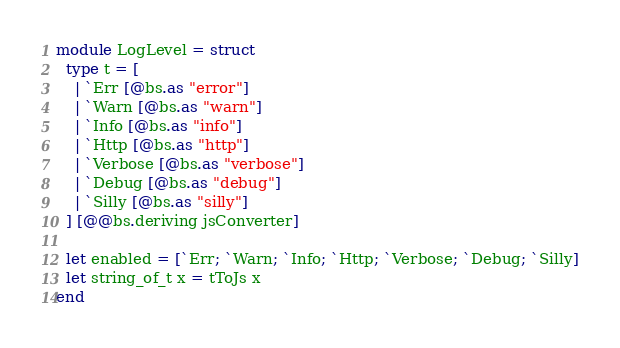Convert code to text. <code><loc_0><loc_0><loc_500><loc_500><_OCaml_>module LogLevel = struct
  type t = [
    | `Err [@bs.as "error"]
    | `Warn [@bs.as "warn"]
    | `Info [@bs.as "info"]
    | `Http [@bs.as "http"]
    | `Verbose [@bs.as "verbose"]
    | `Debug [@bs.as "debug"]
    | `Silly [@bs.as "silly"]
  ] [@@bs.deriving jsConverter]

  let enabled = [`Err; `Warn; `Info; `Http; `Verbose; `Debug; `Silly]
  let string_of_t x = tToJs x
end
</code> 